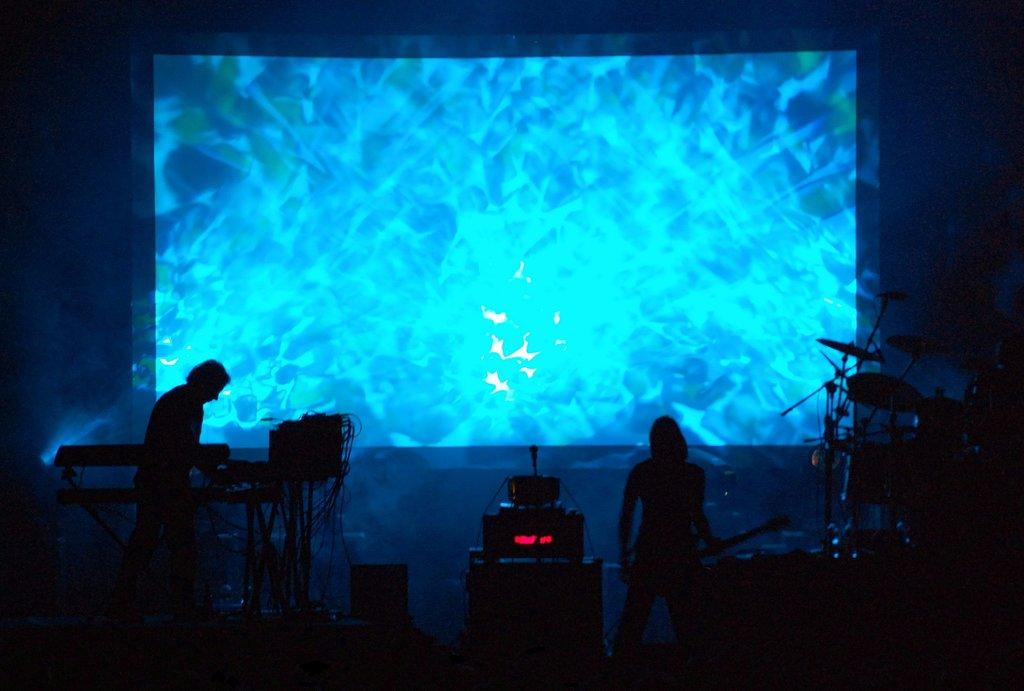What can be seen in the background of the image? There is a screen in the background of the image. Who or what is present in the image? There are people in the image. What else can be seen in the image besides the people? Musical instruments and a microphone are visible in the image. Are there any other objects in the image? Yes, there are additional objects in the image. How many rings are visible on the legs of the people in the image? There are no rings or legs visible in the image; it features people, musical instruments, and a microphone. What type of vacation is being taken in the image? There is no indication of a vacation in the image; it appears to be a performance or gathering involving people, musical instruments, and a microphone. 